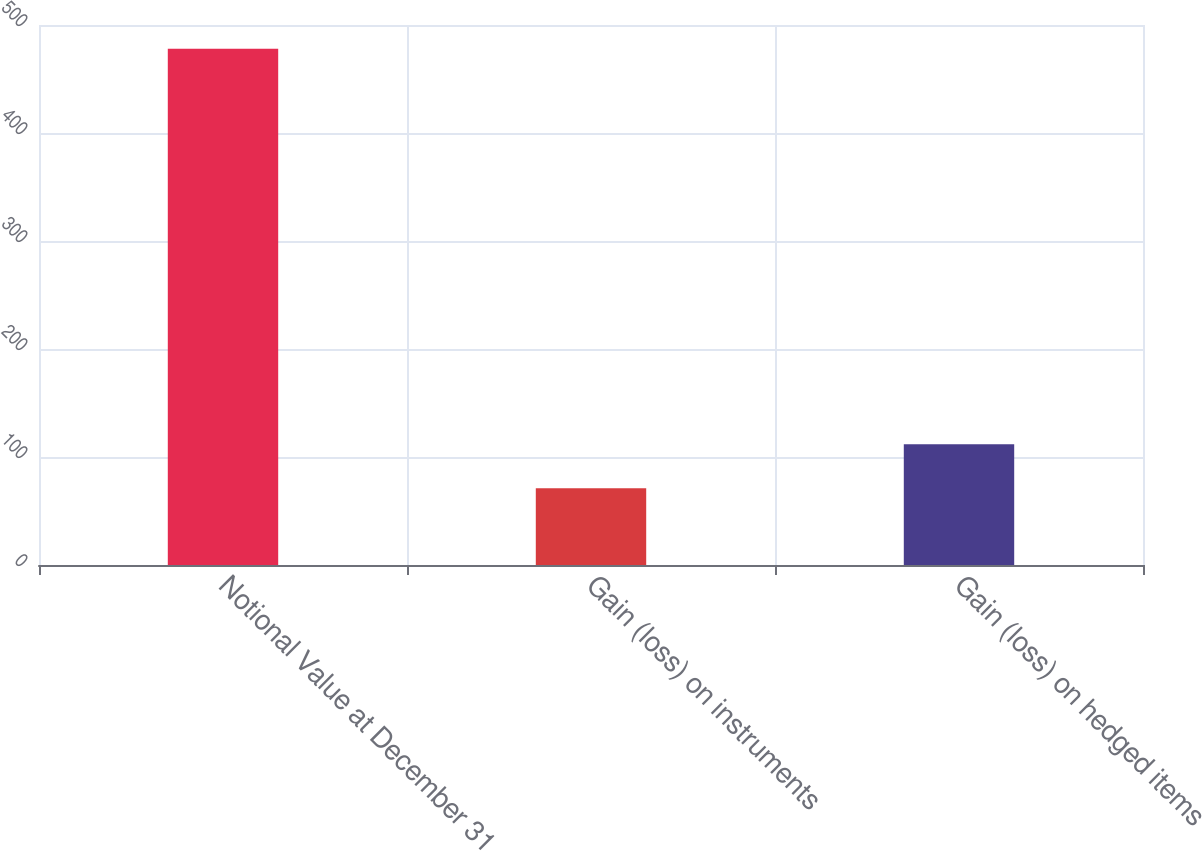Convert chart. <chart><loc_0><loc_0><loc_500><loc_500><bar_chart><fcel>Notional Value at December 31<fcel>Gain (loss) on instruments<fcel>Gain (loss) on hedged items<nl><fcel>478<fcel>71<fcel>111.7<nl></chart> 